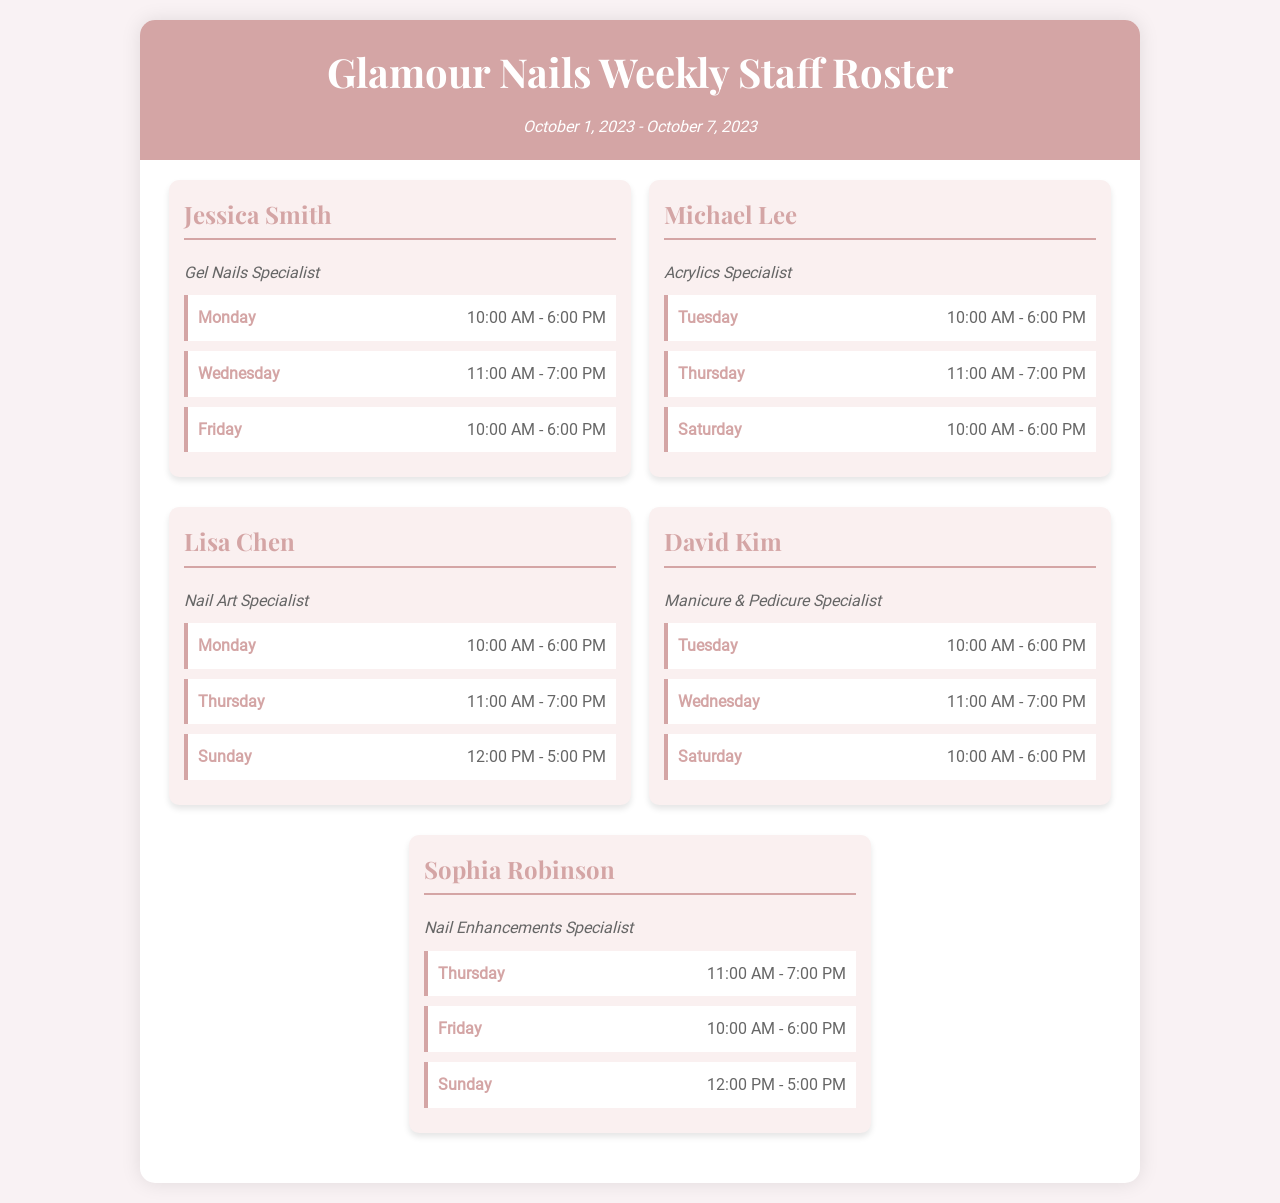What is the date range of the schedule? The date range is indicated at the top of the schedule and shows the period covered by the roster.
Answer: October 1, 2023 - October 7, 2023 Who is the Nail Art Specialist? The schedule lists the technicians along with their specializations, identifying the Nail Art Specialist.
Answer: Lisa Chen On which day does Michael Lee work? The schedule details the shifts for each technician, specifying which day Michael Lee has shifts.
Answer: Tuesday What time does Jessica Smith start her Monday shift? The schedule provides the starting and ending times for each technician's shifts, allowing us to find Jessica's start time on Monday.
Answer: 10:00 AM Which specialization is offered by David Kim? The specialization for each technician is listed directly under their name to identify their area of expertise.
Answer: Manicure & Pedicure Specialist How many shifts does Sophia Robinson have during the week? By counting the shifts listed for Sophia Robinson in the schedule, we can determine the number of shifts she works.
Answer: 3 What is the shift time for Lisa Chen on Sunday? The schedule specifies the shift times for each day, so we look at Lisa Chen's entry for Sunday to find this information.
Answer: 12:00 PM - 5:00 PM Which technician works on Saturday? The document lists the technicians alongside the days they work, revealing who has a shift on Saturday.
Answer: Michael Lee and David Kim On which day does the Gel Nails Specialist not work? By examining the shifts for Jessica Smith, we can identify the day on which she does not have a scheduled shift.
Answer: Tuesday 